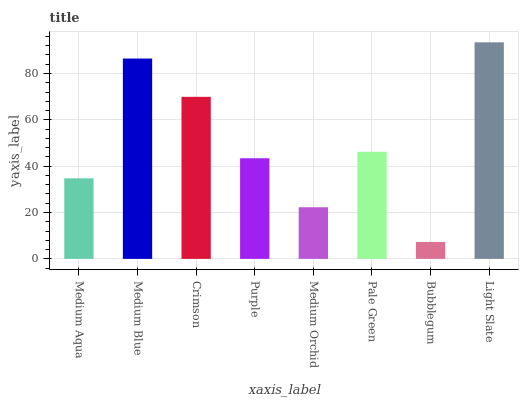Is Medium Blue the minimum?
Answer yes or no. No. Is Medium Blue the maximum?
Answer yes or no. No. Is Medium Blue greater than Medium Aqua?
Answer yes or no. Yes. Is Medium Aqua less than Medium Blue?
Answer yes or no. Yes. Is Medium Aqua greater than Medium Blue?
Answer yes or no. No. Is Medium Blue less than Medium Aqua?
Answer yes or no. No. Is Pale Green the high median?
Answer yes or no. Yes. Is Purple the low median?
Answer yes or no. Yes. Is Light Slate the high median?
Answer yes or no. No. Is Medium Aqua the low median?
Answer yes or no. No. 